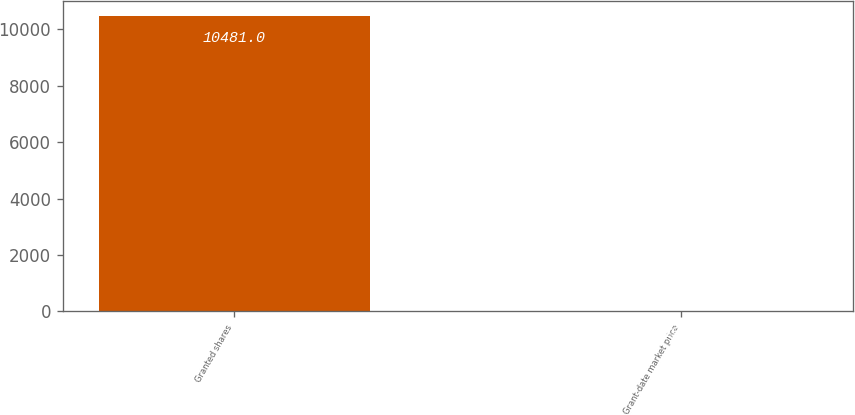Convert chart. <chart><loc_0><loc_0><loc_500><loc_500><bar_chart><fcel>Granted shares<fcel>Grant-date market price<nl><fcel>10481<fcel>19.1<nl></chart> 